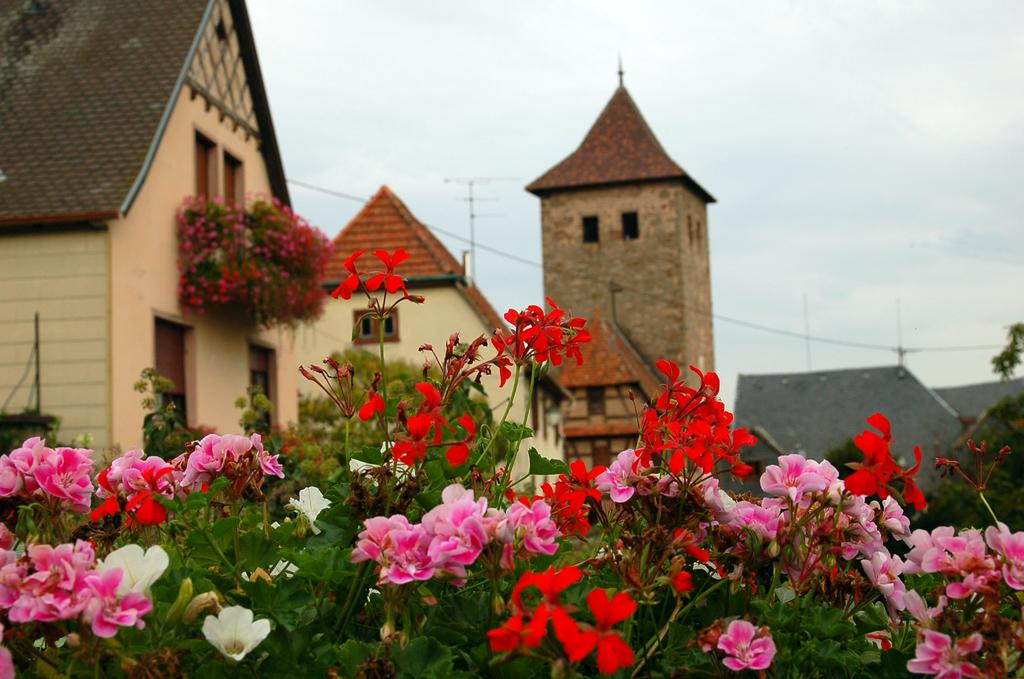What type of natural elements can be seen in the image? There are flowers, plants, trees, and the sky visible in the image. What type of man-made structures are present in the background of the image? There are houses, walls, windows, doors, wires, and an antenna in the background of the image. What is the title of the book that the person is reading in the image? There is no person or book present in the image. What is the position of the authority figure in the image? There is no authority figure present in the image. 